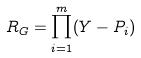Convert formula to latex. <formula><loc_0><loc_0><loc_500><loc_500>R _ { G } = \prod _ { i = 1 } ^ { m } ( Y - P _ { i } )</formula> 